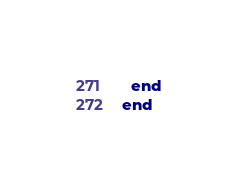Convert code to text. <code><loc_0><loc_0><loc_500><loc_500><_Ruby_>  end
end
</code> 